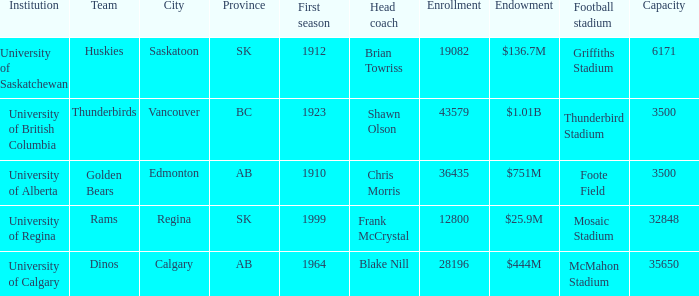How many endowments does Mosaic Stadium have? 1.0. 